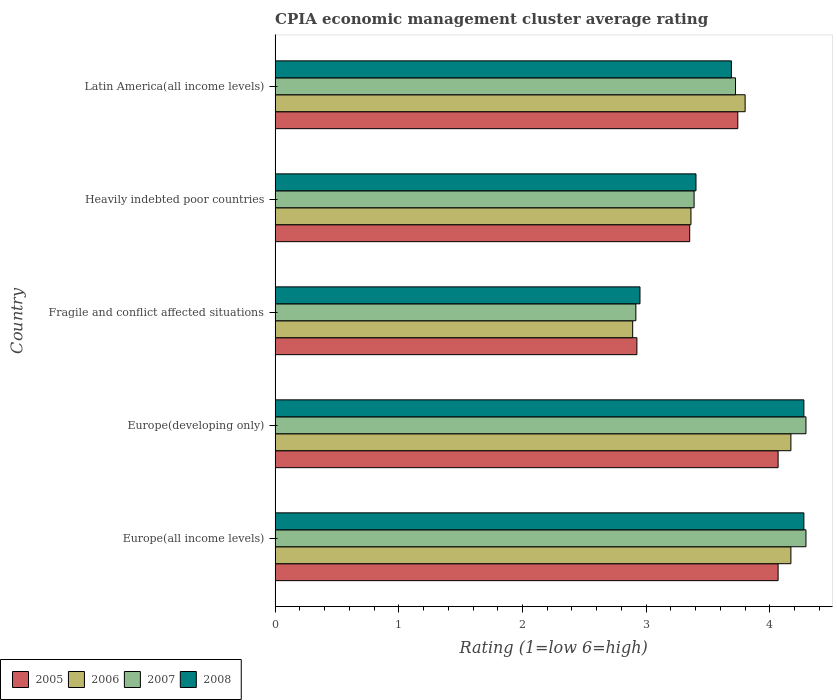How many groups of bars are there?
Keep it short and to the point. 5. Are the number of bars per tick equal to the number of legend labels?
Offer a terse response. Yes. How many bars are there on the 2nd tick from the top?
Offer a terse response. 4. What is the label of the 2nd group of bars from the top?
Ensure brevity in your answer.  Heavily indebted poor countries. What is the CPIA rating in 2008 in Fragile and conflict affected situations?
Provide a succinct answer. 2.95. Across all countries, what is the maximum CPIA rating in 2005?
Your answer should be compact. 4.07. Across all countries, what is the minimum CPIA rating in 2007?
Your answer should be very brief. 2.92. In which country was the CPIA rating in 2005 maximum?
Offer a very short reply. Europe(all income levels). In which country was the CPIA rating in 2006 minimum?
Keep it short and to the point. Fragile and conflict affected situations. What is the total CPIA rating in 2008 in the graph?
Provide a short and direct response. 18.59. What is the difference between the CPIA rating in 2006 in Europe(all income levels) and that in Fragile and conflict affected situations?
Offer a terse response. 1.28. What is the difference between the CPIA rating in 2006 in Latin America(all income levels) and the CPIA rating in 2007 in Europe(all income levels)?
Your answer should be very brief. -0.49. What is the average CPIA rating in 2007 per country?
Give a very brief answer. 3.72. What is the difference between the CPIA rating in 2007 and CPIA rating in 2005 in Heavily indebted poor countries?
Give a very brief answer. 0.04. In how many countries, is the CPIA rating in 2006 greater than 2.8 ?
Make the answer very short. 5. What is the ratio of the CPIA rating in 2007 in Europe(developing only) to that in Fragile and conflict affected situations?
Offer a very short reply. 1.47. Is the difference between the CPIA rating in 2007 in Europe(developing only) and Latin America(all income levels) greater than the difference between the CPIA rating in 2005 in Europe(developing only) and Latin America(all income levels)?
Your answer should be compact. Yes. What is the difference between the highest and the second highest CPIA rating in 2008?
Offer a very short reply. 0. What is the difference between the highest and the lowest CPIA rating in 2007?
Offer a terse response. 1.37. Is the sum of the CPIA rating in 2008 in Europe(developing only) and Latin America(all income levels) greater than the maximum CPIA rating in 2007 across all countries?
Make the answer very short. Yes. What does the 3rd bar from the bottom in Europe(developing only) represents?
Offer a terse response. 2007. Is it the case that in every country, the sum of the CPIA rating in 2005 and CPIA rating in 2008 is greater than the CPIA rating in 2007?
Offer a terse response. Yes. How many bars are there?
Your answer should be compact. 20. Does the graph contain any zero values?
Your response must be concise. No. How are the legend labels stacked?
Make the answer very short. Horizontal. What is the title of the graph?
Ensure brevity in your answer.  CPIA economic management cluster average rating. Does "2012" appear as one of the legend labels in the graph?
Your answer should be compact. No. What is the label or title of the X-axis?
Give a very brief answer. Rating (1=low 6=high). What is the label or title of the Y-axis?
Keep it short and to the point. Country. What is the Rating (1=low 6=high) of 2005 in Europe(all income levels)?
Provide a short and direct response. 4.07. What is the Rating (1=low 6=high) of 2006 in Europe(all income levels)?
Make the answer very short. 4.17. What is the Rating (1=low 6=high) of 2007 in Europe(all income levels)?
Give a very brief answer. 4.29. What is the Rating (1=low 6=high) of 2008 in Europe(all income levels)?
Your response must be concise. 4.28. What is the Rating (1=low 6=high) in 2005 in Europe(developing only)?
Offer a very short reply. 4.07. What is the Rating (1=low 6=high) of 2006 in Europe(developing only)?
Your answer should be very brief. 4.17. What is the Rating (1=low 6=high) in 2007 in Europe(developing only)?
Offer a terse response. 4.29. What is the Rating (1=low 6=high) in 2008 in Europe(developing only)?
Offer a very short reply. 4.28. What is the Rating (1=low 6=high) in 2005 in Fragile and conflict affected situations?
Offer a terse response. 2.92. What is the Rating (1=low 6=high) of 2006 in Fragile and conflict affected situations?
Provide a succinct answer. 2.89. What is the Rating (1=low 6=high) in 2007 in Fragile and conflict affected situations?
Your response must be concise. 2.92. What is the Rating (1=low 6=high) in 2008 in Fragile and conflict affected situations?
Your answer should be compact. 2.95. What is the Rating (1=low 6=high) in 2005 in Heavily indebted poor countries?
Offer a terse response. 3.35. What is the Rating (1=low 6=high) of 2006 in Heavily indebted poor countries?
Your answer should be compact. 3.36. What is the Rating (1=low 6=high) of 2007 in Heavily indebted poor countries?
Your answer should be very brief. 3.39. What is the Rating (1=low 6=high) in 2008 in Heavily indebted poor countries?
Offer a very short reply. 3.4. What is the Rating (1=low 6=high) of 2005 in Latin America(all income levels)?
Your answer should be very brief. 3.74. What is the Rating (1=low 6=high) in 2007 in Latin America(all income levels)?
Your response must be concise. 3.72. What is the Rating (1=low 6=high) of 2008 in Latin America(all income levels)?
Offer a terse response. 3.69. Across all countries, what is the maximum Rating (1=low 6=high) of 2005?
Your answer should be compact. 4.07. Across all countries, what is the maximum Rating (1=low 6=high) in 2006?
Make the answer very short. 4.17. Across all countries, what is the maximum Rating (1=low 6=high) of 2007?
Ensure brevity in your answer.  4.29. Across all countries, what is the maximum Rating (1=low 6=high) in 2008?
Provide a short and direct response. 4.28. Across all countries, what is the minimum Rating (1=low 6=high) in 2005?
Provide a short and direct response. 2.92. Across all countries, what is the minimum Rating (1=low 6=high) of 2006?
Keep it short and to the point. 2.89. Across all countries, what is the minimum Rating (1=low 6=high) of 2007?
Your answer should be compact. 2.92. Across all countries, what is the minimum Rating (1=low 6=high) in 2008?
Offer a terse response. 2.95. What is the total Rating (1=low 6=high) of 2005 in the graph?
Your answer should be compact. 18.15. What is the total Rating (1=low 6=high) in 2006 in the graph?
Ensure brevity in your answer.  18.39. What is the total Rating (1=low 6=high) in 2007 in the graph?
Your response must be concise. 18.61. What is the total Rating (1=low 6=high) in 2008 in the graph?
Keep it short and to the point. 18.59. What is the difference between the Rating (1=low 6=high) in 2005 in Europe(all income levels) and that in Fragile and conflict affected situations?
Keep it short and to the point. 1.14. What is the difference between the Rating (1=low 6=high) in 2006 in Europe(all income levels) and that in Fragile and conflict affected situations?
Make the answer very short. 1.28. What is the difference between the Rating (1=low 6=high) in 2007 in Europe(all income levels) and that in Fragile and conflict affected situations?
Keep it short and to the point. 1.38. What is the difference between the Rating (1=low 6=high) of 2008 in Europe(all income levels) and that in Fragile and conflict affected situations?
Offer a terse response. 1.32. What is the difference between the Rating (1=low 6=high) in 2005 in Europe(all income levels) and that in Heavily indebted poor countries?
Offer a terse response. 0.71. What is the difference between the Rating (1=low 6=high) of 2006 in Europe(all income levels) and that in Heavily indebted poor countries?
Provide a succinct answer. 0.81. What is the difference between the Rating (1=low 6=high) of 2007 in Europe(all income levels) and that in Heavily indebted poor countries?
Make the answer very short. 0.9. What is the difference between the Rating (1=low 6=high) of 2008 in Europe(all income levels) and that in Heavily indebted poor countries?
Provide a succinct answer. 0.87. What is the difference between the Rating (1=low 6=high) in 2005 in Europe(all income levels) and that in Latin America(all income levels)?
Your answer should be compact. 0.33. What is the difference between the Rating (1=low 6=high) in 2006 in Europe(all income levels) and that in Latin America(all income levels)?
Your response must be concise. 0.37. What is the difference between the Rating (1=low 6=high) of 2007 in Europe(all income levels) and that in Latin America(all income levels)?
Provide a short and direct response. 0.57. What is the difference between the Rating (1=low 6=high) in 2008 in Europe(all income levels) and that in Latin America(all income levels)?
Your answer should be compact. 0.59. What is the difference between the Rating (1=low 6=high) in 2005 in Europe(developing only) and that in Fragile and conflict affected situations?
Offer a very short reply. 1.14. What is the difference between the Rating (1=low 6=high) in 2006 in Europe(developing only) and that in Fragile and conflict affected situations?
Your answer should be compact. 1.28. What is the difference between the Rating (1=low 6=high) of 2007 in Europe(developing only) and that in Fragile and conflict affected situations?
Give a very brief answer. 1.38. What is the difference between the Rating (1=low 6=high) of 2008 in Europe(developing only) and that in Fragile and conflict affected situations?
Your answer should be very brief. 1.32. What is the difference between the Rating (1=low 6=high) in 2005 in Europe(developing only) and that in Heavily indebted poor countries?
Your answer should be compact. 0.71. What is the difference between the Rating (1=low 6=high) in 2006 in Europe(developing only) and that in Heavily indebted poor countries?
Your answer should be very brief. 0.81. What is the difference between the Rating (1=low 6=high) of 2007 in Europe(developing only) and that in Heavily indebted poor countries?
Your answer should be compact. 0.9. What is the difference between the Rating (1=low 6=high) of 2008 in Europe(developing only) and that in Heavily indebted poor countries?
Provide a short and direct response. 0.87. What is the difference between the Rating (1=low 6=high) in 2005 in Europe(developing only) and that in Latin America(all income levels)?
Ensure brevity in your answer.  0.33. What is the difference between the Rating (1=low 6=high) of 2006 in Europe(developing only) and that in Latin America(all income levels)?
Offer a very short reply. 0.37. What is the difference between the Rating (1=low 6=high) of 2007 in Europe(developing only) and that in Latin America(all income levels)?
Provide a short and direct response. 0.57. What is the difference between the Rating (1=low 6=high) in 2008 in Europe(developing only) and that in Latin America(all income levels)?
Provide a succinct answer. 0.59. What is the difference between the Rating (1=low 6=high) in 2005 in Fragile and conflict affected situations and that in Heavily indebted poor countries?
Provide a short and direct response. -0.43. What is the difference between the Rating (1=low 6=high) of 2006 in Fragile and conflict affected situations and that in Heavily indebted poor countries?
Your response must be concise. -0.47. What is the difference between the Rating (1=low 6=high) in 2007 in Fragile and conflict affected situations and that in Heavily indebted poor countries?
Ensure brevity in your answer.  -0.47. What is the difference between the Rating (1=low 6=high) of 2008 in Fragile and conflict affected situations and that in Heavily indebted poor countries?
Make the answer very short. -0.45. What is the difference between the Rating (1=low 6=high) of 2005 in Fragile and conflict affected situations and that in Latin America(all income levels)?
Give a very brief answer. -0.82. What is the difference between the Rating (1=low 6=high) in 2006 in Fragile and conflict affected situations and that in Latin America(all income levels)?
Offer a very short reply. -0.91. What is the difference between the Rating (1=low 6=high) in 2007 in Fragile and conflict affected situations and that in Latin America(all income levels)?
Offer a very short reply. -0.81. What is the difference between the Rating (1=low 6=high) of 2008 in Fragile and conflict affected situations and that in Latin America(all income levels)?
Your answer should be compact. -0.74. What is the difference between the Rating (1=low 6=high) in 2005 in Heavily indebted poor countries and that in Latin America(all income levels)?
Make the answer very short. -0.39. What is the difference between the Rating (1=low 6=high) of 2006 in Heavily indebted poor countries and that in Latin America(all income levels)?
Give a very brief answer. -0.44. What is the difference between the Rating (1=low 6=high) of 2007 in Heavily indebted poor countries and that in Latin America(all income levels)?
Provide a succinct answer. -0.33. What is the difference between the Rating (1=low 6=high) in 2008 in Heavily indebted poor countries and that in Latin America(all income levels)?
Your answer should be very brief. -0.29. What is the difference between the Rating (1=low 6=high) of 2005 in Europe(all income levels) and the Rating (1=low 6=high) of 2006 in Europe(developing only)?
Ensure brevity in your answer.  -0.1. What is the difference between the Rating (1=low 6=high) in 2005 in Europe(all income levels) and the Rating (1=low 6=high) in 2007 in Europe(developing only)?
Your answer should be compact. -0.23. What is the difference between the Rating (1=low 6=high) in 2005 in Europe(all income levels) and the Rating (1=low 6=high) in 2008 in Europe(developing only)?
Offer a very short reply. -0.21. What is the difference between the Rating (1=low 6=high) in 2006 in Europe(all income levels) and the Rating (1=low 6=high) in 2007 in Europe(developing only)?
Your answer should be very brief. -0.12. What is the difference between the Rating (1=low 6=high) in 2006 in Europe(all income levels) and the Rating (1=low 6=high) in 2008 in Europe(developing only)?
Provide a short and direct response. -0.1. What is the difference between the Rating (1=low 6=high) in 2007 in Europe(all income levels) and the Rating (1=low 6=high) in 2008 in Europe(developing only)?
Give a very brief answer. 0.02. What is the difference between the Rating (1=low 6=high) in 2005 in Europe(all income levels) and the Rating (1=low 6=high) in 2006 in Fragile and conflict affected situations?
Your answer should be very brief. 1.18. What is the difference between the Rating (1=low 6=high) in 2005 in Europe(all income levels) and the Rating (1=low 6=high) in 2007 in Fragile and conflict affected situations?
Your answer should be compact. 1.15. What is the difference between the Rating (1=low 6=high) in 2005 in Europe(all income levels) and the Rating (1=low 6=high) in 2008 in Fragile and conflict affected situations?
Keep it short and to the point. 1.12. What is the difference between the Rating (1=low 6=high) of 2006 in Europe(all income levels) and the Rating (1=low 6=high) of 2007 in Fragile and conflict affected situations?
Offer a very short reply. 1.25. What is the difference between the Rating (1=low 6=high) in 2006 in Europe(all income levels) and the Rating (1=low 6=high) in 2008 in Fragile and conflict affected situations?
Your response must be concise. 1.22. What is the difference between the Rating (1=low 6=high) of 2007 in Europe(all income levels) and the Rating (1=low 6=high) of 2008 in Fragile and conflict affected situations?
Keep it short and to the point. 1.34. What is the difference between the Rating (1=low 6=high) in 2005 in Europe(all income levels) and the Rating (1=low 6=high) in 2006 in Heavily indebted poor countries?
Keep it short and to the point. 0.7. What is the difference between the Rating (1=low 6=high) of 2005 in Europe(all income levels) and the Rating (1=low 6=high) of 2007 in Heavily indebted poor countries?
Ensure brevity in your answer.  0.68. What is the difference between the Rating (1=low 6=high) of 2005 in Europe(all income levels) and the Rating (1=low 6=high) of 2008 in Heavily indebted poor countries?
Ensure brevity in your answer.  0.66. What is the difference between the Rating (1=low 6=high) of 2006 in Europe(all income levels) and the Rating (1=low 6=high) of 2007 in Heavily indebted poor countries?
Ensure brevity in your answer.  0.78. What is the difference between the Rating (1=low 6=high) in 2006 in Europe(all income levels) and the Rating (1=low 6=high) in 2008 in Heavily indebted poor countries?
Keep it short and to the point. 0.77. What is the difference between the Rating (1=low 6=high) in 2007 in Europe(all income levels) and the Rating (1=low 6=high) in 2008 in Heavily indebted poor countries?
Your answer should be very brief. 0.89. What is the difference between the Rating (1=low 6=high) in 2005 in Europe(all income levels) and the Rating (1=low 6=high) in 2006 in Latin America(all income levels)?
Provide a short and direct response. 0.27. What is the difference between the Rating (1=low 6=high) of 2005 in Europe(all income levels) and the Rating (1=low 6=high) of 2007 in Latin America(all income levels)?
Provide a short and direct response. 0.34. What is the difference between the Rating (1=low 6=high) of 2005 in Europe(all income levels) and the Rating (1=low 6=high) of 2008 in Latin America(all income levels)?
Keep it short and to the point. 0.38. What is the difference between the Rating (1=low 6=high) in 2006 in Europe(all income levels) and the Rating (1=low 6=high) in 2007 in Latin America(all income levels)?
Provide a short and direct response. 0.45. What is the difference between the Rating (1=low 6=high) of 2006 in Europe(all income levels) and the Rating (1=low 6=high) of 2008 in Latin America(all income levels)?
Make the answer very short. 0.48. What is the difference between the Rating (1=low 6=high) of 2007 in Europe(all income levels) and the Rating (1=low 6=high) of 2008 in Latin America(all income levels)?
Your response must be concise. 0.6. What is the difference between the Rating (1=low 6=high) of 2005 in Europe(developing only) and the Rating (1=low 6=high) of 2006 in Fragile and conflict affected situations?
Keep it short and to the point. 1.18. What is the difference between the Rating (1=low 6=high) of 2005 in Europe(developing only) and the Rating (1=low 6=high) of 2007 in Fragile and conflict affected situations?
Offer a terse response. 1.15. What is the difference between the Rating (1=low 6=high) in 2005 in Europe(developing only) and the Rating (1=low 6=high) in 2008 in Fragile and conflict affected situations?
Provide a succinct answer. 1.12. What is the difference between the Rating (1=low 6=high) of 2006 in Europe(developing only) and the Rating (1=low 6=high) of 2007 in Fragile and conflict affected situations?
Provide a short and direct response. 1.25. What is the difference between the Rating (1=low 6=high) of 2006 in Europe(developing only) and the Rating (1=low 6=high) of 2008 in Fragile and conflict affected situations?
Your answer should be very brief. 1.22. What is the difference between the Rating (1=low 6=high) in 2007 in Europe(developing only) and the Rating (1=low 6=high) in 2008 in Fragile and conflict affected situations?
Your answer should be very brief. 1.34. What is the difference between the Rating (1=low 6=high) of 2005 in Europe(developing only) and the Rating (1=low 6=high) of 2006 in Heavily indebted poor countries?
Your response must be concise. 0.7. What is the difference between the Rating (1=low 6=high) of 2005 in Europe(developing only) and the Rating (1=low 6=high) of 2007 in Heavily indebted poor countries?
Provide a succinct answer. 0.68. What is the difference between the Rating (1=low 6=high) of 2005 in Europe(developing only) and the Rating (1=low 6=high) of 2008 in Heavily indebted poor countries?
Your answer should be compact. 0.66. What is the difference between the Rating (1=low 6=high) in 2006 in Europe(developing only) and the Rating (1=low 6=high) in 2007 in Heavily indebted poor countries?
Ensure brevity in your answer.  0.78. What is the difference between the Rating (1=low 6=high) of 2006 in Europe(developing only) and the Rating (1=low 6=high) of 2008 in Heavily indebted poor countries?
Provide a succinct answer. 0.77. What is the difference between the Rating (1=low 6=high) in 2007 in Europe(developing only) and the Rating (1=low 6=high) in 2008 in Heavily indebted poor countries?
Ensure brevity in your answer.  0.89. What is the difference between the Rating (1=low 6=high) of 2005 in Europe(developing only) and the Rating (1=low 6=high) of 2006 in Latin America(all income levels)?
Offer a terse response. 0.27. What is the difference between the Rating (1=low 6=high) of 2005 in Europe(developing only) and the Rating (1=low 6=high) of 2007 in Latin America(all income levels)?
Your response must be concise. 0.34. What is the difference between the Rating (1=low 6=high) of 2005 in Europe(developing only) and the Rating (1=low 6=high) of 2008 in Latin America(all income levels)?
Offer a terse response. 0.38. What is the difference between the Rating (1=low 6=high) of 2006 in Europe(developing only) and the Rating (1=low 6=high) of 2007 in Latin America(all income levels)?
Your response must be concise. 0.45. What is the difference between the Rating (1=low 6=high) in 2006 in Europe(developing only) and the Rating (1=low 6=high) in 2008 in Latin America(all income levels)?
Keep it short and to the point. 0.48. What is the difference between the Rating (1=low 6=high) of 2007 in Europe(developing only) and the Rating (1=low 6=high) of 2008 in Latin America(all income levels)?
Keep it short and to the point. 0.6. What is the difference between the Rating (1=low 6=high) of 2005 in Fragile and conflict affected situations and the Rating (1=low 6=high) of 2006 in Heavily indebted poor countries?
Your response must be concise. -0.44. What is the difference between the Rating (1=low 6=high) in 2005 in Fragile and conflict affected situations and the Rating (1=low 6=high) in 2007 in Heavily indebted poor countries?
Provide a short and direct response. -0.46. What is the difference between the Rating (1=low 6=high) in 2005 in Fragile and conflict affected situations and the Rating (1=low 6=high) in 2008 in Heavily indebted poor countries?
Provide a short and direct response. -0.48. What is the difference between the Rating (1=low 6=high) in 2006 in Fragile and conflict affected situations and the Rating (1=low 6=high) in 2007 in Heavily indebted poor countries?
Provide a short and direct response. -0.5. What is the difference between the Rating (1=low 6=high) of 2006 in Fragile and conflict affected situations and the Rating (1=low 6=high) of 2008 in Heavily indebted poor countries?
Offer a terse response. -0.51. What is the difference between the Rating (1=low 6=high) in 2007 in Fragile and conflict affected situations and the Rating (1=low 6=high) in 2008 in Heavily indebted poor countries?
Your answer should be very brief. -0.49. What is the difference between the Rating (1=low 6=high) of 2005 in Fragile and conflict affected situations and the Rating (1=low 6=high) of 2006 in Latin America(all income levels)?
Keep it short and to the point. -0.88. What is the difference between the Rating (1=low 6=high) in 2005 in Fragile and conflict affected situations and the Rating (1=low 6=high) in 2007 in Latin America(all income levels)?
Keep it short and to the point. -0.8. What is the difference between the Rating (1=low 6=high) in 2005 in Fragile and conflict affected situations and the Rating (1=low 6=high) in 2008 in Latin America(all income levels)?
Offer a very short reply. -0.76. What is the difference between the Rating (1=low 6=high) of 2006 in Fragile and conflict affected situations and the Rating (1=low 6=high) of 2007 in Latin America(all income levels)?
Ensure brevity in your answer.  -0.83. What is the difference between the Rating (1=low 6=high) in 2006 in Fragile and conflict affected situations and the Rating (1=low 6=high) in 2008 in Latin America(all income levels)?
Give a very brief answer. -0.8. What is the difference between the Rating (1=low 6=high) in 2007 in Fragile and conflict affected situations and the Rating (1=low 6=high) in 2008 in Latin America(all income levels)?
Your answer should be compact. -0.77. What is the difference between the Rating (1=low 6=high) in 2005 in Heavily indebted poor countries and the Rating (1=low 6=high) in 2006 in Latin America(all income levels)?
Offer a very short reply. -0.45. What is the difference between the Rating (1=low 6=high) of 2005 in Heavily indebted poor countries and the Rating (1=low 6=high) of 2007 in Latin America(all income levels)?
Make the answer very short. -0.37. What is the difference between the Rating (1=low 6=high) of 2005 in Heavily indebted poor countries and the Rating (1=low 6=high) of 2008 in Latin America(all income levels)?
Provide a short and direct response. -0.34. What is the difference between the Rating (1=low 6=high) of 2006 in Heavily indebted poor countries and the Rating (1=low 6=high) of 2007 in Latin America(all income levels)?
Keep it short and to the point. -0.36. What is the difference between the Rating (1=low 6=high) of 2006 in Heavily indebted poor countries and the Rating (1=low 6=high) of 2008 in Latin America(all income levels)?
Provide a short and direct response. -0.33. What is the difference between the Rating (1=low 6=high) in 2007 in Heavily indebted poor countries and the Rating (1=low 6=high) in 2008 in Latin America(all income levels)?
Offer a terse response. -0.3. What is the average Rating (1=low 6=high) in 2005 per country?
Your answer should be very brief. 3.63. What is the average Rating (1=low 6=high) in 2006 per country?
Your answer should be very brief. 3.68. What is the average Rating (1=low 6=high) of 2007 per country?
Your response must be concise. 3.72. What is the average Rating (1=low 6=high) in 2008 per country?
Ensure brevity in your answer.  3.72. What is the difference between the Rating (1=low 6=high) of 2005 and Rating (1=low 6=high) of 2006 in Europe(all income levels)?
Give a very brief answer. -0.1. What is the difference between the Rating (1=low 6=high) of 2005 and Rating (1=low 6=high) of 2007 in Europe(all income levels)?
Make the answer very short. -0.23. What is the difference between the Rating (1=low 6=high) in 2005 and Rating (1=low 6=high) in 2008 in Europe(all income levels)?
Provide a succinct answer. -0.21. What is the difference between the Rating (1=low 6=high) in 2006 and Rating (1=low 6=high) in 2007 in Europe(all income levels)?
Give a very brief answer. -0.12. What is the difference between the Rating (1=low 6=high) in 2006 and Rating (1=low 6=high) in 2008 in Europe(all income levels)?
Give a very brief answer. -0.1. What is the difference between the Rating (1=low 6=high) in 2007 and Rating (1=low 6=high) in 2008 in Europe(all income levels)?
Give a very brief answer. 0.02. What is the difference between the Rating (1=low 6=high) of 2005 and Rating (1=low 6=high) of 2006 in Europe(developing only)?
Your answer should be compact. -0.1. What is the difference between the Rating (1=low 6=high) in 2005 and Rating (1=low 6=high) in 2007 in Europe(developing only)?
Offer a terse response. -0.23. What is the difference between the Rating (1=low 6=high) in 2005 and Rating (1=low 6=high) in 2008 in Europe(developing only)?
Keep it short and to the point. -0.21. What is the difference between the Rating (1=low 6=high) in 2006 and Rating (1=low 6=high) in 2007 in Europe(developing only)?
Offer a very short reply. -0.12. What is the difference between the Rating (1=low 6=high) in 2006 and Rating (1=low 6=high) in 2008 in Europe(developing only)?
Your response must be concise. -0.1. What is the difference between the Rating (1=low 6=high) of 2007 and Rating (1=low 6=high) of 2008 in Europe(developing only)?
Keep it short and to the point. 0.02. What is the difference between the Rating (1=low 6=high) of 2005 and Rating (1=low 6=high) of 2006 in Fragile and conflict affected situations?
Ensure brevity in your answer.  0.03. What is the difference between the Rating (1=low 6=high) in 2005 and Rating (1=low 6=high) in 2007 in Fragile and conflict affected situations?
Provide a short and direct response. 0.01. What is the difference between the Rating (1=low 6=high) in 2005 and Rating (1=low 6=high) in 2008 in Fragile and conflict affected situations?
Make the answer very short. -0.03. What is the difference between the Rating (1=low 6=high) in 2006 and Rating (1=low 6=high) in 2007 in Fragile and conflict affected situations?
Your answer should be compact. -0.03. What is the difference between the Rating (1=low 6=high) of 2006 and Rating (1=low 6=high) of 2008 in Fragile and conflict affected situations?
Make the answer very short. -0.06. What is the difference between the Rating (1=low 6=high) in 2007 and Rating (1=low 6=high) in 2008 in Fragile and conflict affected situations?
Offer a terse response. -0.03. What is the difference between the Rating (1=low 6=high) of 2005 and Rating (1=low 6=high) of 2006 in Heavily indebted poor countries?
Offer a terse response. -0.01. What is the difference between the Rating (1=low 6=high) in 2005 and Rating (1=low 6=high) in 2007 in Heavily indebted poor countries?
Provide a succinct answer. -0.04. What is the difference between the Rating (1=low 6=high) in 2005 and Rating (1=low 6=high) in 2008 in Heavily indebted poor countries?
Make the answer very short. -0.05. What is the difference between the Rating (1=low 6=high) of 2006 and Rating (1=low 6=high) of 2007 in Heavily indebted poor countries?
Offer a terse response. -0.03. What is the difference between the Rating (1=low 6=high) in 2006 and Rating (1=low 6=high) in 2008 in Heavily indebted poor countries?
Offer a very short reply. -0.04. What is the difference between the Rating (1=low 6=high) of 2007 and Rating (1=low 6=high) of 2008 in Heavily indebted poor countries?
Provide a succinct answer. -0.02. What is the difference between the Rating (1=low 6=high) of 2005 and Rating (1=low 6=high) of 2006 in Latin America(all income levels)?
Provide a short and direct response. -0.06. What is the difference between the Rating (1=low 6=high) of 2005 and Rating (1=low 6=high) of 2007 in Latin America(all income levels)?
Your response must be concise. 0.02. What is the difference between the Rating (1=low 6=high) in 2005 and Rating (1=low 6=high) in 2008 in Latin America(all income levels)?
Ensure brevity in your answer.  0.05. What is the difference between the Rating (1=low 6=high) in 2006 and Rating (1=low 6=high) in 2007 in Latin America(all income levels)?
Ensure brevity in your answer.  0.08. What is the ratio of the Rating (1=low 6=high) in 2005 in Europe(all income levels) to that in Europe(developing only)?
Your answer should be very brief. 1. What is the ratio of the Rating (1=low 6=high) in 2006 in Europe(all income levels) to that in Europe(developing only)?
Give a very brief answer. 1. What is the ratio of the Rating (1=low 6=high) of 2008 in Europe(all income levels) to that in Europe(developing only)?
Provide a short and direct response. 1. What is the ratio of the Rating (1=low 6=high) in 2005 in Europe(all income levels) to that in Fragile and conflict affected situations?
Your answer should be compact. 1.39. What is the ratio of the Rating (1=low 6=high) of 2006 in Europe(all income levels) to that in Fragile and conflict affected situations?
Provide a succinct answer. 1.44. What is the ratio of the Rating (1=low 6=high) in 2007 in Europe(all income levels) to that in Fragile and conflict affected situations?
Make the answer very short. 1.47. What is the ratio of the Rating (1=low 6=high) in 2008 in Europe(all income levels) to that in Fragile and conflict affected situations?
Your answer should be compact. 1.45. What is the ratio of the Rating (1=low 6=high) in 2005 in Europe(all income levels) to that in Heavily indebted poor countries?
Offer a terse response. 1.21. What is the ratio of the Rating (1=low 6=high) in 2006 in Europe(all income levels) to that in Heavily indebted poor countries?
Provide a succinct answer. 1.24. What is the ratio of the Rating (1=low 6=high) of 2007 in Europe(all income levels) to that in Heavily indebted poor countries?
Offer a very short reply. 1.27. What is the ratio of the Rating (1=low 6=high) in 2008 in Europe(all income levels) to that in Heavily indebted poor countries?
Keep it short and to the point. 1.26. What is the ratio of the Rating (1=low 6=high) in 2005 in Europe(all income levels) to that in Latin America(all income levels)?
Provide a succinct answer. 1.09. What is the ratio of the Rating (1=low 6=high) in 2006 in Europe(all income levels) to that in Latin America(all income levels)?
Offer a very short reply. 1.1. What is the ratio of the Rating (1=low 6=high) in 2007 in Europe(all income levels) to that in Latin America(all income levels)?
Give a very brief answer. 1.15. What is the ratio of the Rating (1=low 6=high) in 2008 in Europe(all income levels) to that in Latin America(all income levels)?
Offer a terse response. 1.16. What is the ratio of the Rating (1=low 6=high) of 2005 in Europe(developing only) to that in Fragile and conflict affected situations?
Make the answer very short. 1.39. What is the ratio of the Rating (1=low 6=high) in 2006 in Europe(developing only) to that in Fragile and conflict affected situations?
Offer a very short reply. 1.44. What is the ratio of the Rating (1=low 6=high) of 2007 in Europe(developing only) to that in Fragile and conflict affected situations?
Provide a short and direct response. 1.47. What is the ratio of the Rating (1=low 6=high) in 2008 in Europe(developing only) to that in Fragile and conflict affected situations?
Make the answer very short. 1.45. What is the ratio of the Rating (1=low 6=high) of 2005 in Europe(developing only) to that in Heavily indebted poor countries?
Your answer should be very brief. 1.21. What is the ratio of the Rating (1=low 6=high) in 2006 in Europe(developing only) to that in Heavily indebted poor countries?
Provide a succinct answer. 1.24. What is the ratio of the Rating (1=low 6=high) of 2007 in Europe(developing only) to that in Heavily indebted poor countries?
Provide a succinct answer. 1.27. What is the ratio of the Rating (1=low 6=high) in 2008 in Europe(developing only) to that in Heavily indebted poor countries?
Offer a very short reply. 1.26. What is the ratio of the Rating (1=low 6=high) of 2005 in Europe(developing only) to that in Latin America(all income levels)?
Make the answer very short. 1.09. What is the ratio of the Rating (1=low 6=high) in 2006 in Europe(developing only) to that in Latin America(all income levels)?
Make the answer very short. 1.1. What is the ratio of the Rating (1=low 6=high) of 2007 in Europe(developing only) to that in Latin America(all income levels)?
Ensure brevity in your answer.  1.15. What is the ratio of the Rating (1=low 6=high) of 2008 in Europe(developing only) to that in Latin America(all income levels)?
Ensure brevity in your answer.  1.16. What is the ratio of the Rating (1=low 6=high) of 2005 in Fragile and conflict affected situations to that in Heavily indebted poor countries?
Provide a short and direct response. 0.87. What is the ratio of the Rating (1=low 6=high) of 2006 in Fragile and conflict affected situations to that in Heavily indebted poor countries?
Offer a very short reply. 0.86. What is the ratio of the Rating (1=low 6=high) of 2007 in Fragile and conflict affected situations to that in Heavily indebted poor countries?
Ensure brevity in your answer.  0.86. What is the ratio of the Rating (1=low 6=high) in 2008 in Fragile and conflict affected situations to that in Heavily indebted poor countries?
Make the answer very short. 0.87. What is the ratio of the Rating (1=low 6=high) in 2005 in Fragile and conflict affected situations to that in Latin America(all income levels)?
Make the answer very short. 0.78. What is the ratio of the Rating (1=low 6=high) of 2006 in Fragile and conflict affected situations to that in Latin America(all income levels)?
Make the answer very short. 0.76. What is the ratio of the Rating (1=low 6=high) of 2007 in Fragile and conflict affected situations to that in Latin America(all income levels)?
Provide a succinct answer. 0.78. What is the ratio of the Rating (1=low 6=high) in 2008 in Fragile and conflict affected situations to that in Latin America(all income levels)?
Provide a short and direct response. 0.8. What is the ratio of the Rating (1=low 6=high) of 2005 in Heavily indebted poor countries to that in Latin America(all income levels)?
Give a very brief answer. 0.9. What is the ratio of the Rating (1=low 6=high) in 2006 in Heavily indebted poor countries to that in Latin America(all income levels)?
Your answer should be very brief. 0.88. What is the ratio of the Rating (1=low 6=high) of 2007 in Heavily indebted poor countries to that in Latin America(all income levels)?
Provide a succinct answer. 0.91. What is the ratio of the Rating (1=low 6=high) of 2008 in Heavily indebted poor countries to that in Latin America(all income levels)?
Give a very brief answer. 0.92. What is the difference between the highest and the second highest Rating (1=low 6=high) in 2005?
Make the answer very short. 0. What is the difference between the highest and the second highest Rating (1=low 6=high) in 2007?
Give a very brief answer. 0. What is the difference between the highest and the lowest Rating (1=low 6=high) in 2005?
Offer a terse response. 1.14. What is the difference between the highest and the lowest Rating (1=low 6=high) of 2006?
Offer a very short reply. 1.28. What is the difference between the highest and the lowest Rating (1=low 6=high) of 2007?
Your response must be concise. 1.38. What is the difference between the highest and the lowest Rating (1=low 6=high) of 2008?
Ensure brevity in your answer.  1.32. 